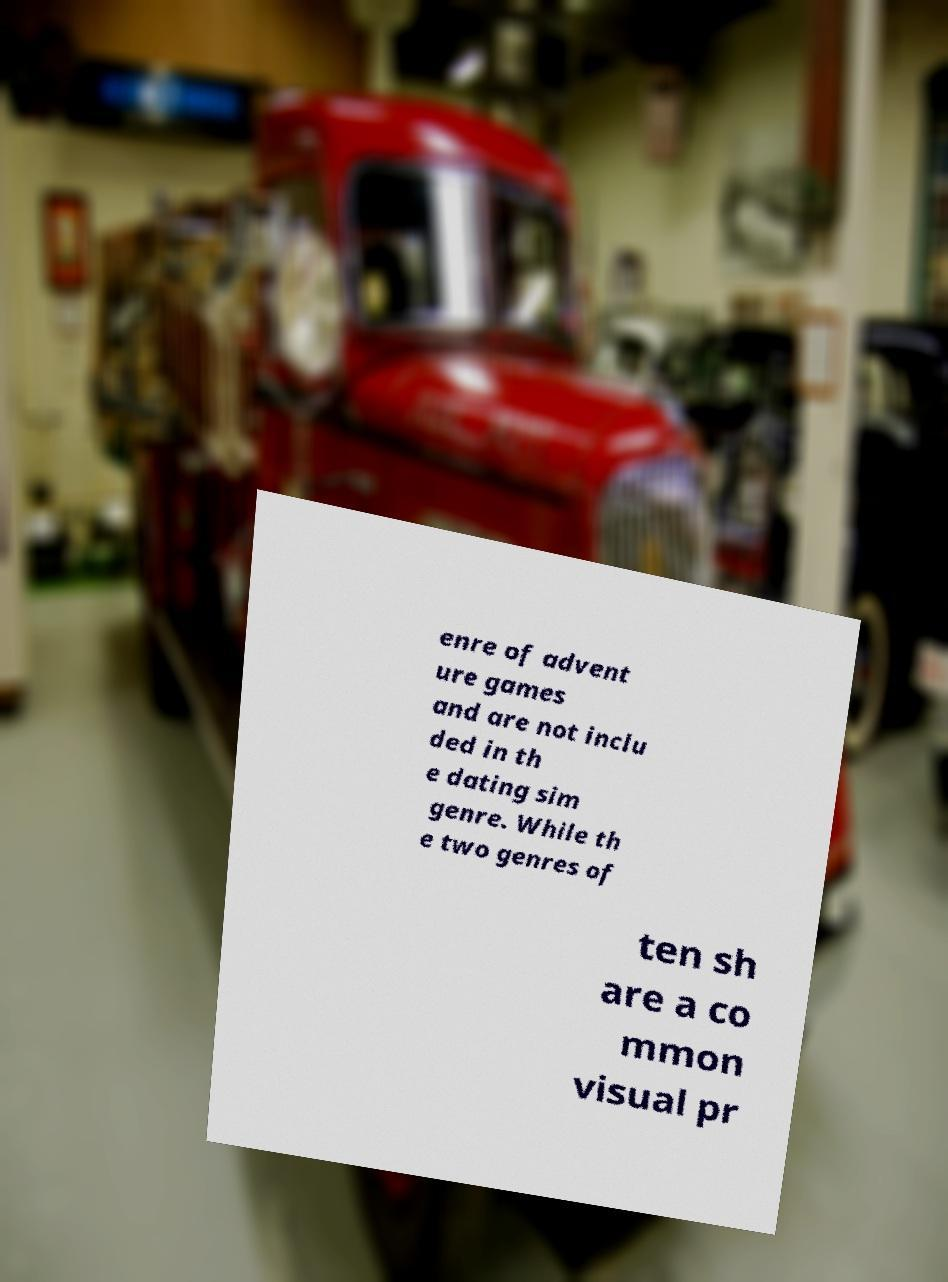I need the written content from this picture converted into text. Can you do that? enre of advent ure games and are not inclu ded in th e dating sim genre. While th e two genres of ten sh are a co mmon visual pr 